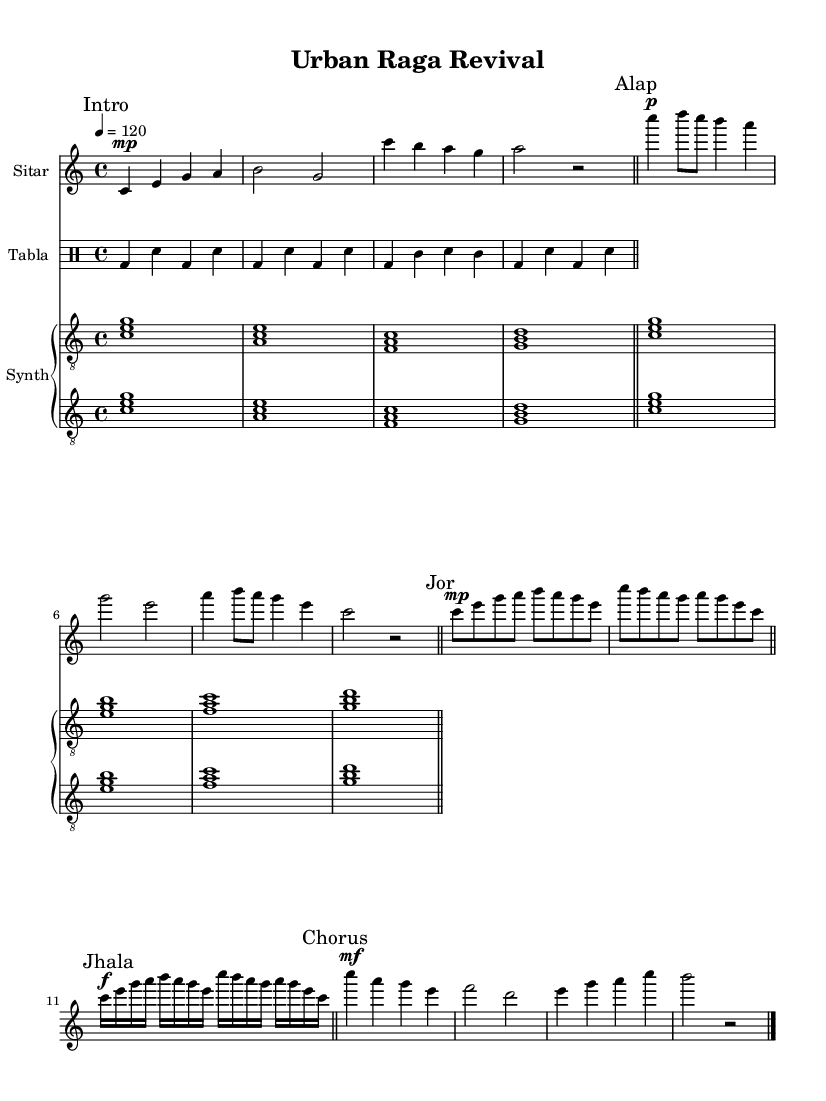What is the key signature of this music? The key signature is C major, which has no sharps or flats as indicated in the global key declaration following the `\key` command.
Answer: C major What is the time signature of this composition? The time signature is 4/4, which is indicated in the global time signature declaration following the `\time` command.
Answer: 4/4 What is the tempo marking for the piece? The tempo marking is 120 beats per minute, indicated in the global tempo declaration following the `\tempo` command.
Answer: 120 How many distinct sections are there in the sitar part? The sitar part contains five distinct sections: Intro, Alap, Jor, Jhala, and Chorus, as marked in the music with corresponding labels.
Answer: Five What rhythm does the tabla follow in the first two measures? The tabla follows a bass-drum and snare rhythm pattern in alternating measures throughout the first two measures.
Answer: Bass-drum and snare What technique is primarily featured in the "Jhala" section? The "Jhala" section primarily features rapid oscillations and playing techniques that represent the dynamic aspect of Indian classical music through fast note sequences.
Answer: Rapid oscillations Which instrument plays a sustained chord in the second measure of the synth part? The synth instrument plays a sustained chord in the second measure, specifically the chord A-C-E, which is indicated through note placement and stem direction.
Answer: A-C-E 